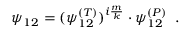<formula> <loc_0><loc_0><loc_500><loc_500>\psi _ { 1 2 } = ( \psi _ { 1 2 } ^ { ( T ) } ) ^ { i \frac { m } { k } } \cdot \psi _ { 1 2 } ^ { ( P ) } \, .</formula> 